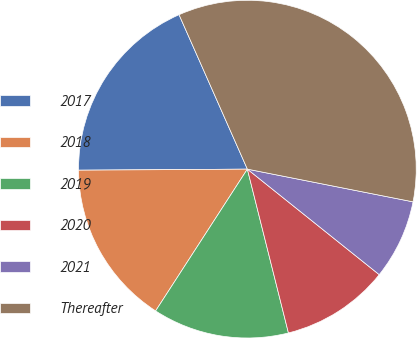Convert chart to OTSL. <chart><loc_0><loc_0><loc_500><loc_500><pie_chart><fcel>2017<fcel>2018<fcel>2019<fcel>2020<fcel>2021<fcel>Thereafter<nl><fcel>18.47%<fcel>15.76%<fcel>13.05%<fcel>10.35%<fcel>7.64%<fcel>34.73%<nl></chart> 